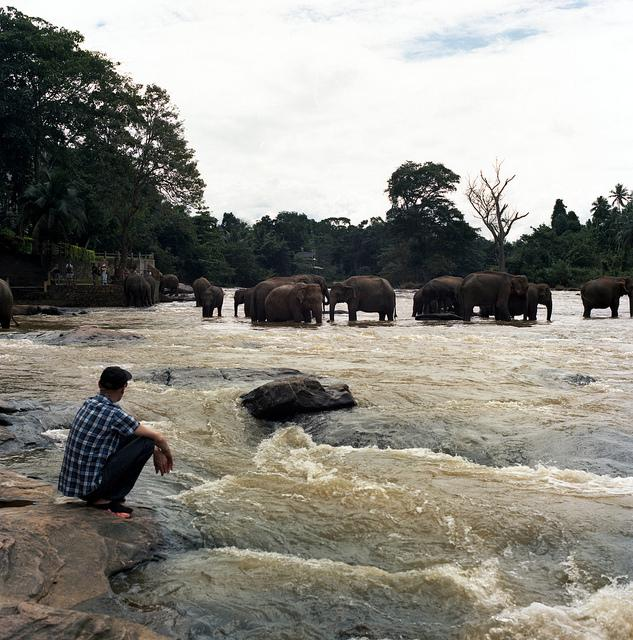What poses the greatest immediate danger to the man? water 